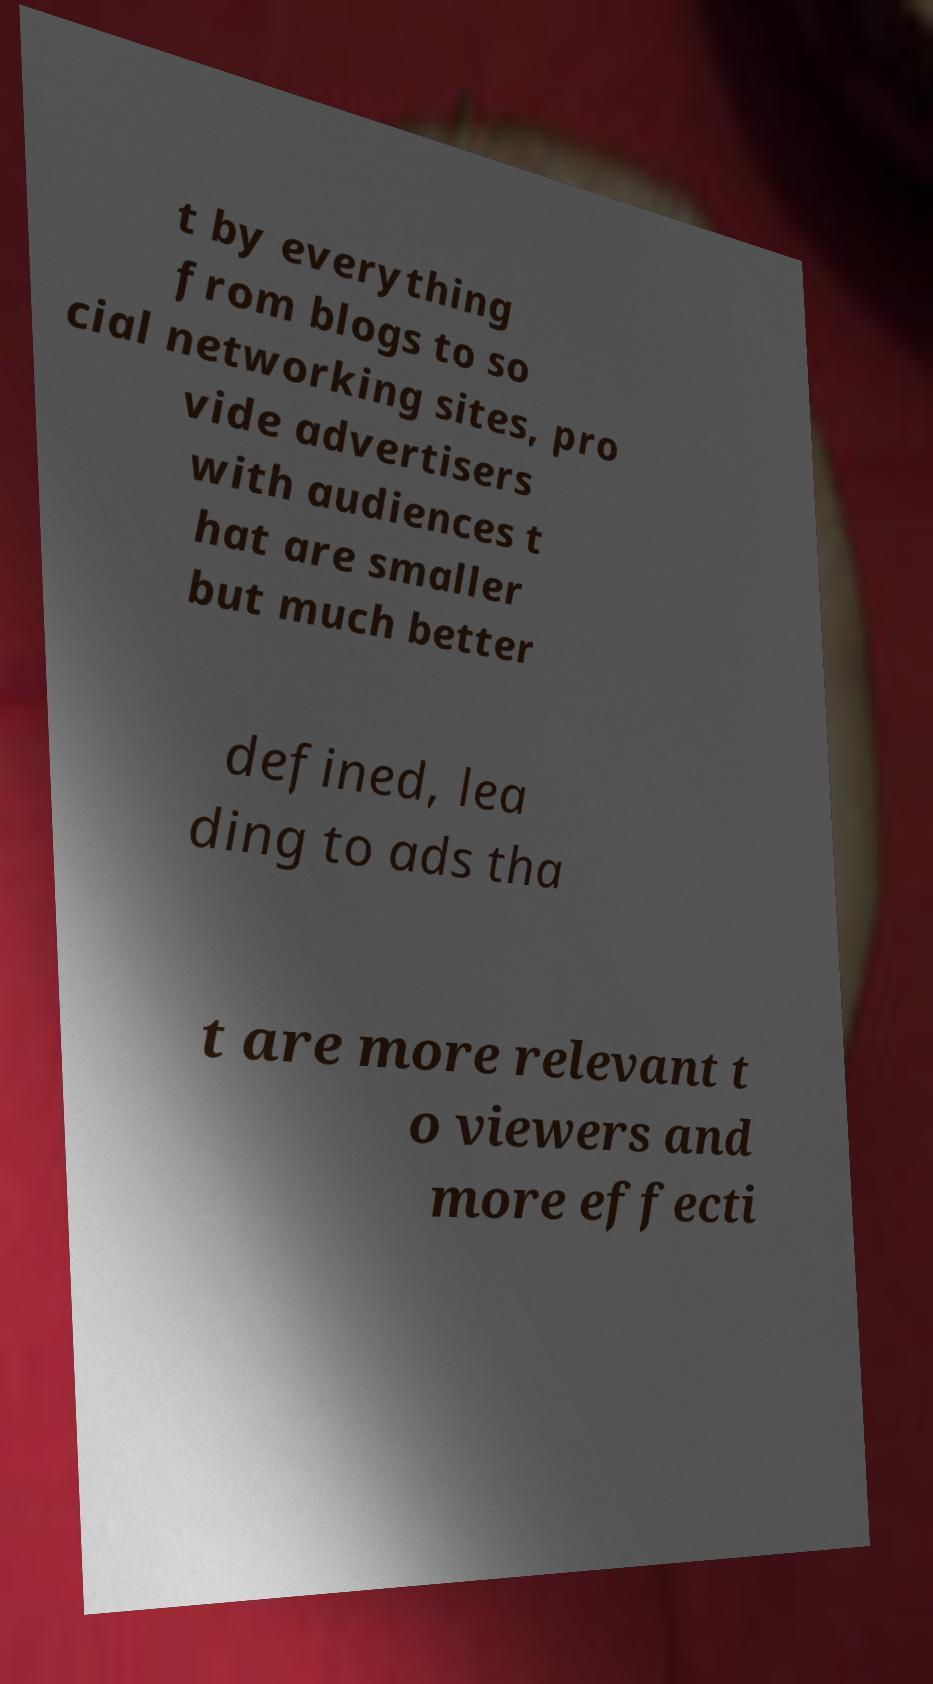Please read and relay the text visible in this image. What does it say? t by everything from blogs to so cial networking sites, pro vide advertisers with audiences t hat are smaller but much better defined, lea ding to ads tha t are more relevant t o viewers and more effecti 